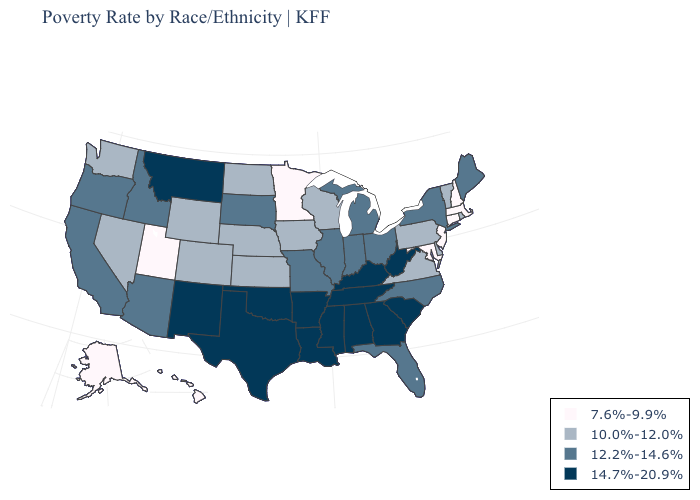Name the states that have a value in the range 10.0%-12.0%?
Give a very brief answer. Colorado, Delaware, Iowa, Kansas, Nebraska, Nevada, North Dakota, Pennsylvania, Rhode Island, Vermont, Virginia, Washington, Wisconsin, Wyoming. What is the value of Iowa?
Give a very brief answer. 10.0%-12.0%. Which states hav the highest value in the South?
Short answer required. Alabama, Arkansas, Georgia, Kentucky, Louisiana, Mississippi, Oklahoma, South Carolina, Tennessee, Texas, West Virginia. Among the states that border Indiana , does Kentucky have the lowest value?
Give a very brief answer. No. What is the highest value in the West ?
Write a very short answer. 14.7%-20.9%. What is the lowest value in the MidWest?
Be succinct. 7.6%-9.9%. Does the first symbol in the legend represent the smallest category?
Give a very brief answer. Yes. What is the lowest value in states that border Kansas?
Short answer required. 10.0%-12.0%. Among the states that border Maine , which have the highest value?
Be succinct. New Hampshire. What is the value of Arizona?
Give a very brief answer. 12.2%-14.6%. Does the first symbol in the legend represent the smallest category?
Answer briefly. Yes. Does Iowa have the highest value in the USA?
Write a very short answer. No. Name the states that have a value in the range 10.0%-12.0%?
Concise answer only. Colorado, Delaware, Iowa, Kansas, Nebraska, Nevada, North Dakota, Pennsylvania, Rhode Island, Vermont, Virginia, Washington, Wisconsin, Wyoming. Does Rhode Island have the highest value in the Northeast?
Give a very brief answer. No. Does Iowa have the lowest value in the MidWest?
Keep it brief. No. 